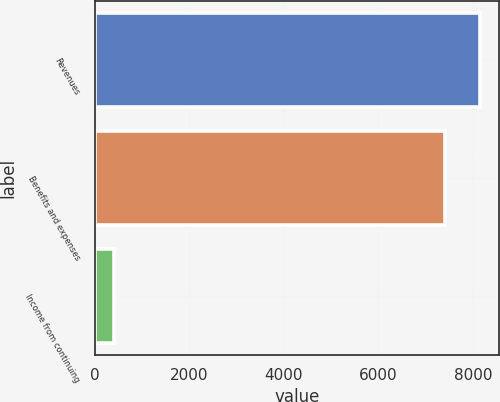Convert chart to OTSL. <chart><loc_0><loc_0><loc_500><loc_500><bar_chart><fcel>Revenues<fcel>Benefits and expenses<fcel>Income from continuing<nl><fcel>8149.9<fcel>7409<fcel>403<nl></chart> 